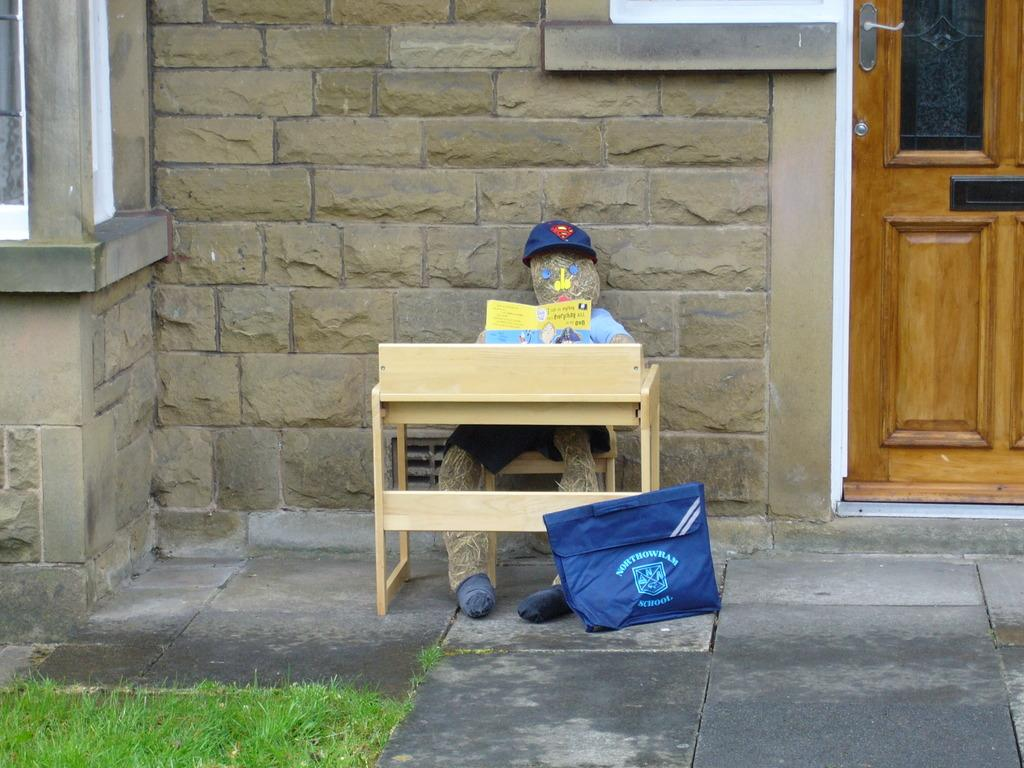What type of structure is visible in the image? There is a house in the image. What can be seen on the table in the image? There is a toy person and a book on the table in the image. What object is present for carrying items in the image? There is a bag in the image. What type of natural environment is visible in the image? There is grass visible in the image. What type of sticks are being used for the discussion in the image? There is no discussion or sticks present in the image. 